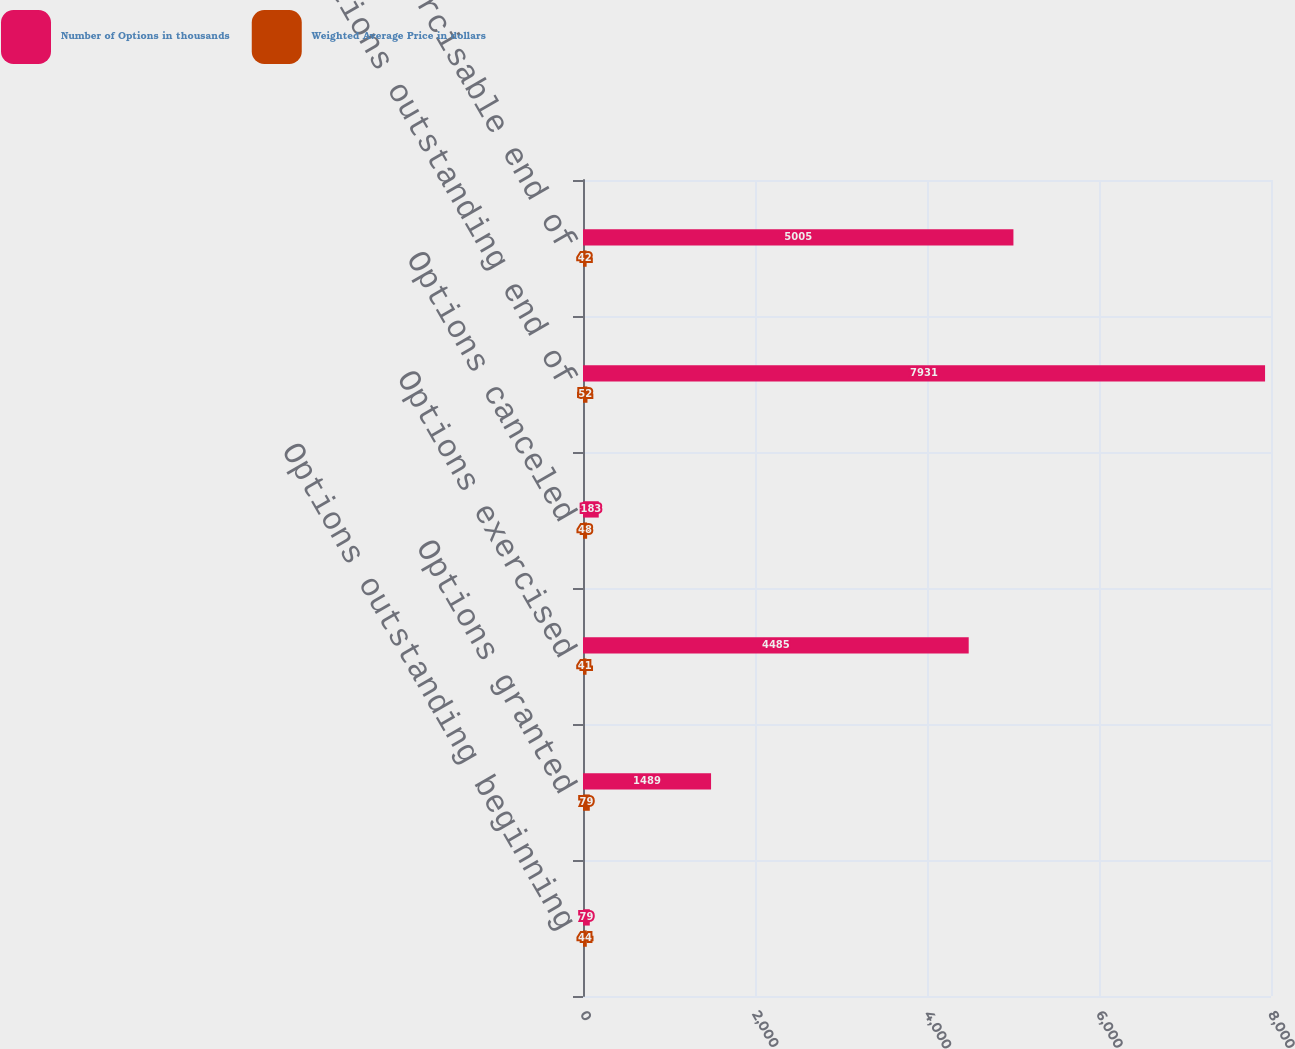Convert chart. <chart><loc_0><loc_0><loc_500><loc_500><stacked_bar_chart><ecel><fcel>Options outstanding beginning<fcel>Options granted<fcel>Options exercised<fcel>Options canceled<fcel>Options outstanding end of<fcel>Options exercisable end of<nl><fcel>Number of Options in thousands<fcel>79<fcel>1489<fcel>4485<fcel>183<fcel>7931<fcel>5005<nl><fcel>Weighted Average Price in dollars<fcel>44<fcel>79<fcel>41<fcel>48<fcel>52<fcel>42<nl></chart> 